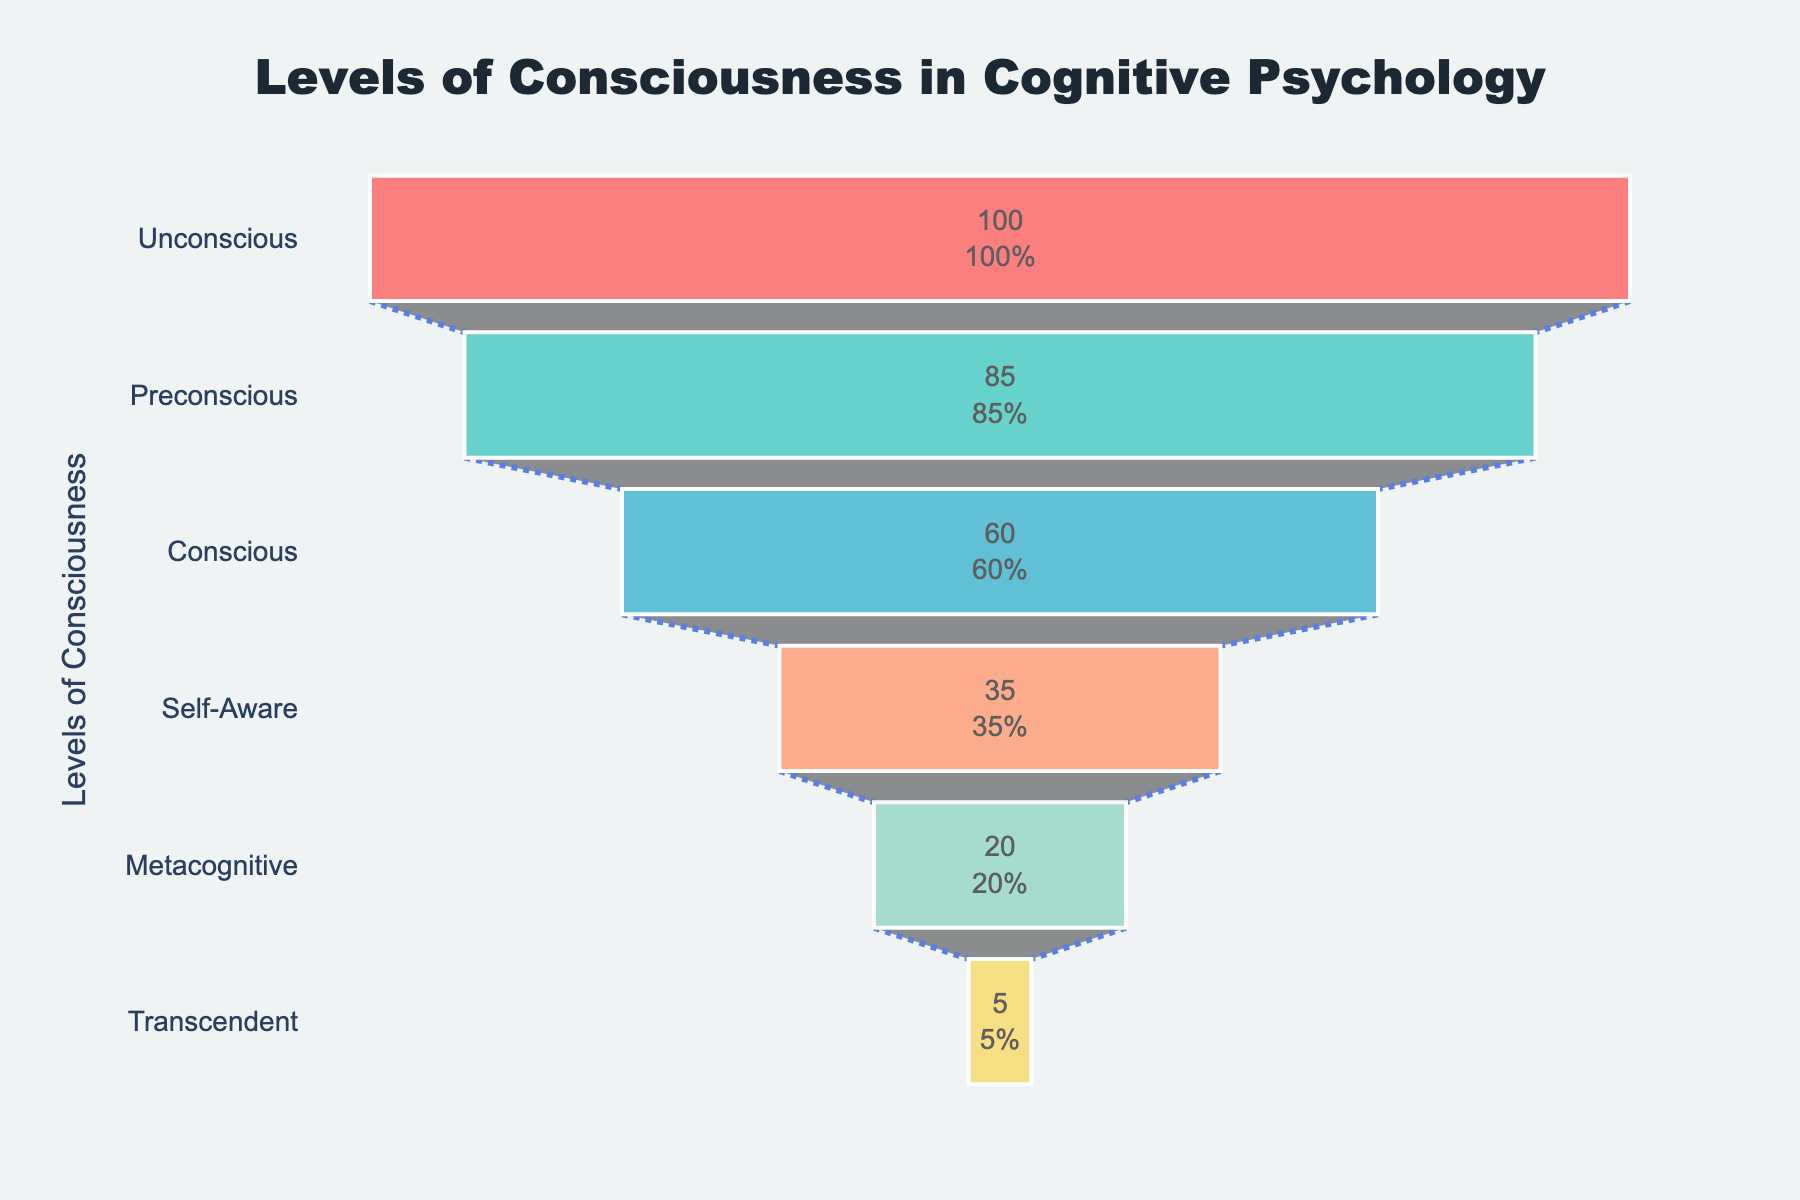What is the title of the funnel chart? The title of the funnel chart is displayed prominently at the top of the figure and usually provides a summary of what the chart is about. In this case, it is written as "Levels of Consciousness in Cognitive Psychology".
Answer: Levels of Consciousness in Cognitive Psychology How many levels of consciousness are depicted in the chart? The number of levels can be determined by counting the distinct categories on the vertical y-axis. Each level represents a different stage of consciousness.
Answer: 6 Which level of consciousness has the highest percentage? To find the level with the highest percentage, look at the funnel section with the largest value on the x-axis scale. This is usually the topmost section in a funnel chart. The Unconscious level has the highest percentage at 100%.
Answer: Unconscious What is the difference in percentage between the Conscious and Metacognitive levels? First, identify the percentage values for both Conscious (60%) and Metacognitive (20%) levels. Then, subtract the Metacognitive percentage from the Conscious percentage (60% - 20%).
Answer: 40% Which level shows a percentage right at the midpoint between the highest and the lowest levels? The highest level is Unconscious with 100%, and the lowest is Transcendent with 5%. The midpoint between 100% and 5% is (100% + 5%) / 2 = 52.5%. The level closest to this value in the chart is the Conscious level at 60%.
Answer: Conscious What is the percentage of the Preconscious level relative to the highest level? To calculate this, divide the Preconscious percentage (85%) by the highest percentage (100%) and convert it to a percentage by multiplying by 100. (85/100)*100 = 85%.
Answer: 85% Which levels have a percentage greater than 50%? Identify the levels with percentages greater than 50% by looking at their values on the x-axis. These levels are Unconscious (100%), Preconscious (85%), and Conscious (60%).
Answer: Unconscious, Preconscious, Conscious What is the average percentage of all the levels of consciousness combined? First, sum up the percentage values of all levels: 100% + 85% + 60% + 35% + 20% + 5% = 305%. Then, divide this sum by the number of levels (6) to find the average: 305% / 6 ≈ 50.8%.
Answer: 50.8% What is the combined percentage of the top three levels? Add the percentages of the top three levels: Unconscious (100%), Preconscious (85%), and Conscious (60%). 100% + 85% + 60% = 245%.
Answer: 245% What trend is indicated by the funnel chart? Funnel charts depict a decreasing trend from top to bottom. In this case, the percentage of individuals in various levels of consciousness decreases progressively from Unconscious to Transcendent, indicating that fewer individuals achieve higher levels of consciousness.
Answer: Decreasing trend 